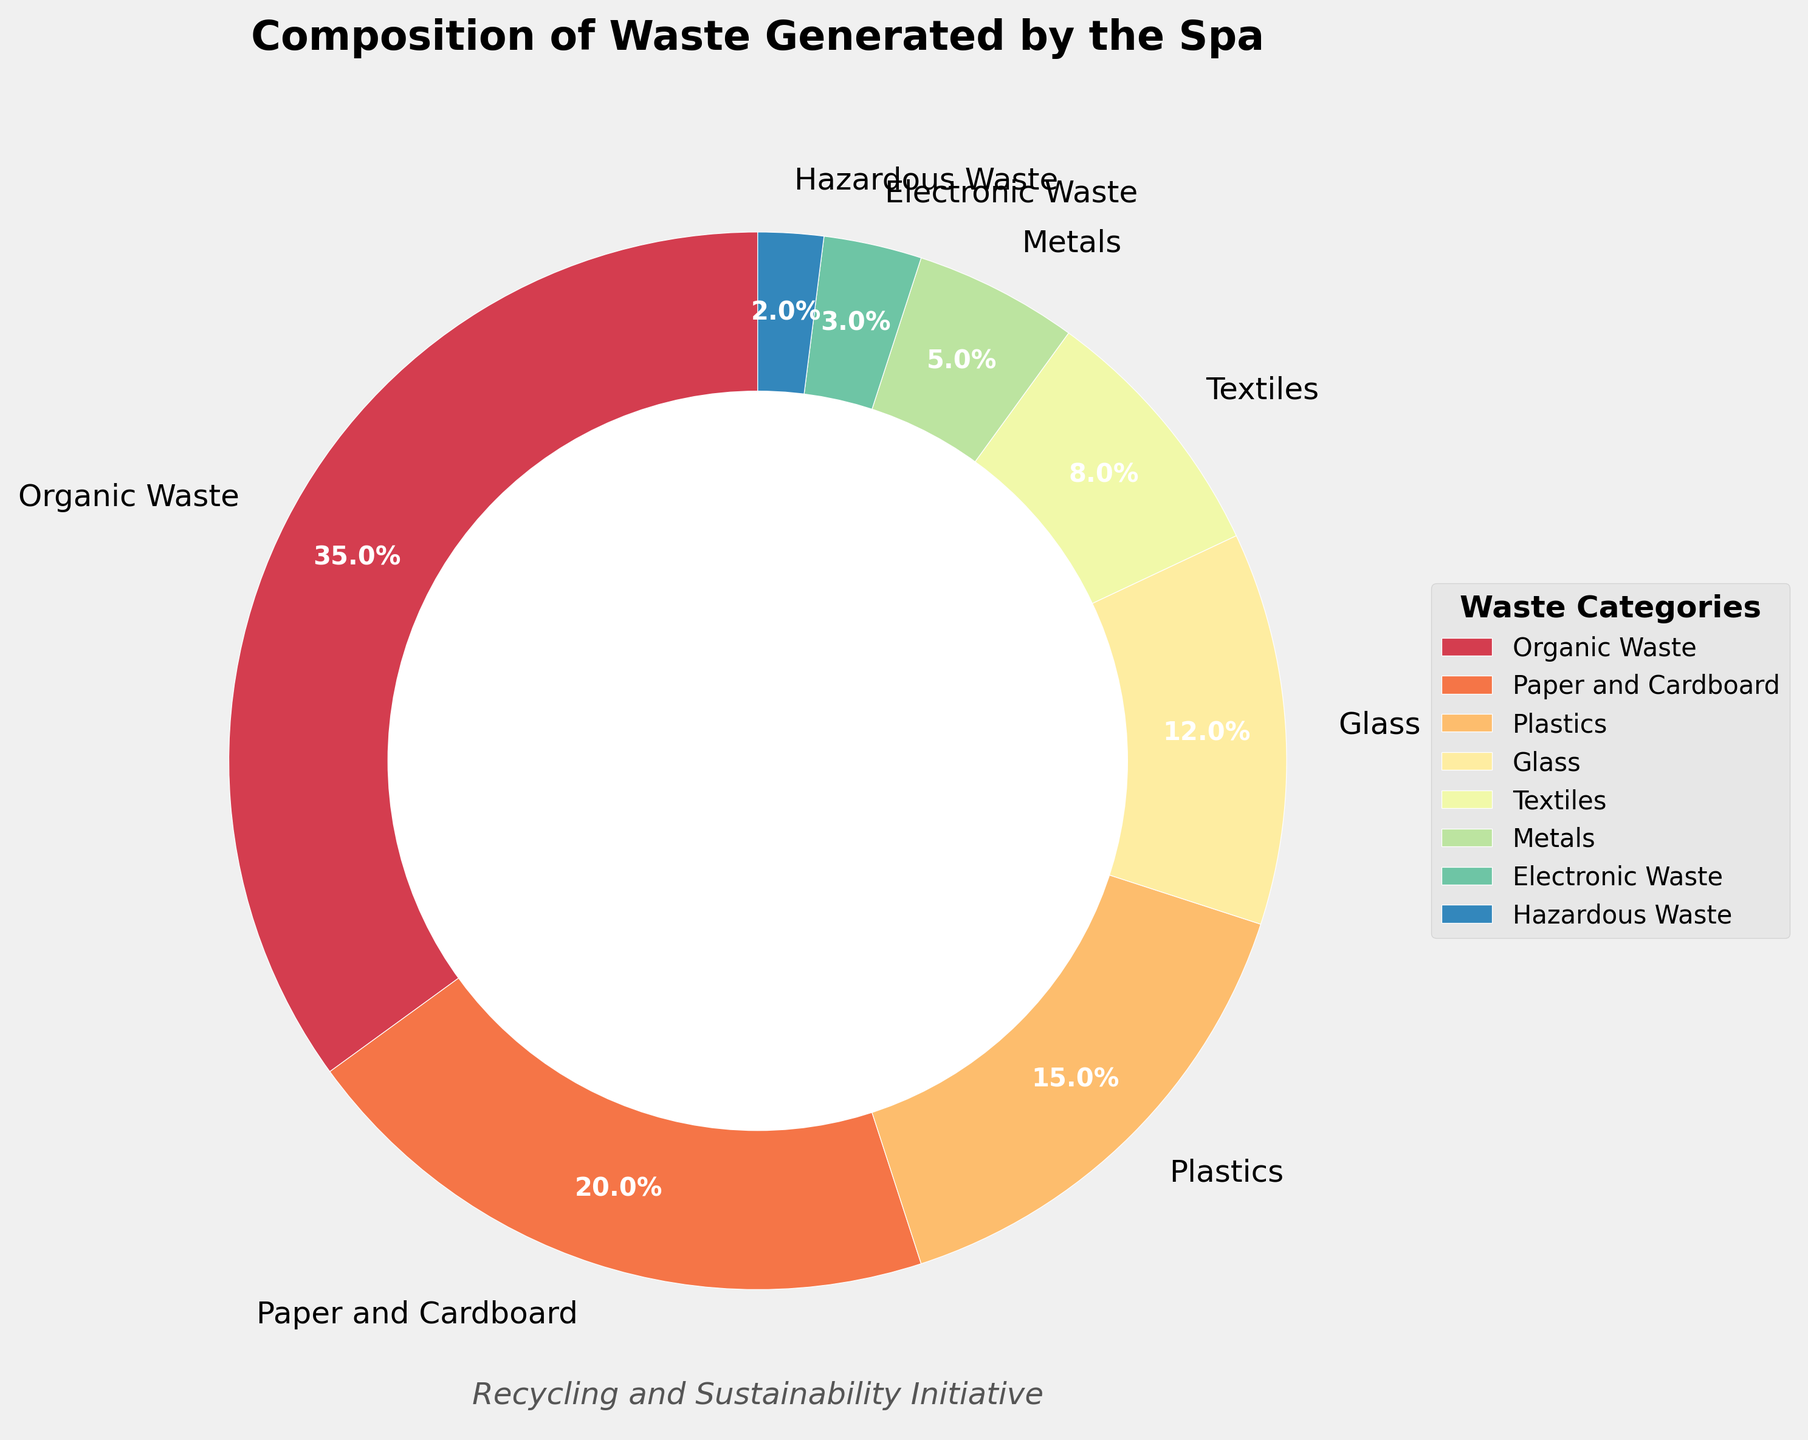Which category accounts for the largest percentage of waste? By observing the size of the wedges and their respective labels, we can see that the wedge labeled "Organic Waste" is the largest, with a percentage label of 35%.
Answer: Organic Waste How much more Organic Waste is generated compared to Plastics? The percentage of Organic Waste is 35%, and the percentage of Plastics is 15%. To find the difference, we subtract the percentage of Plastics from the percentage of Organic Waste: 35% - 15% = 20%.
Answer: 20% What is the combined percentage of Paper and Cardboard, Textiles, and Electronic Waste? Sum the percentages of Paper and Cardboard (20%), Textiles (8%), and Electronic Waste (3%) to get the total combined percentage: 20% + 8% + 3% = 31%.
Answer: 31% Which category has the smallest percentage of waste, and what is its exact value? By examining the labels and percentages, we see that "Hazardous Waste" has the smallest wedge in the pie chart with a value of 2%.
Answer: Hazardous Waste, 2% Is the percentage of Metals higher or lower than the percentage of Glass? By comparing the labels and the wedge sizes, we see that Metals are at 5%, while Glass is at 12%. Therefore, the percentage of Metals is lower than that of Glass.
Answer: Lower Which waste categories together make up exactly 50% of the total waste? Sum the percentages of various categories to find combinations that equal 50%. Organic Waste (35%) and Paper and Cardboard (20%) together exceed 50%. The correct combination is Organic Waste (35%) and Plastics (15%), whose sum is 35% + 15% = 50%.
Answer: Organic Waste and Plastics What is the percentage difference between Textiles and Electronic Waste? To find the difference, subtract the percentage of Electronic Waste (3%) from the percentage of Textiles (8%): 8% - 3% = 5%.
Answer: 5% How does the percentage of Textiles compare to that of Metals? Comparing the wedges and their labels, Textiles account for 8% while Metals account for 5%. Textiles have a higher percentage than Metals.
Answer: Textiles have a higher percentage What is the total percentage of categories that individually account for less than 10% of the waste? Sum the percentages of Textiles (8%), Metals (5%), Electronic Waste (3%), and Hazardous Waste (2%): 8% + 5% + 3% + 2% = 18%.
Answer: 18% What is the difference between the combined percentage of categories with more than 10% waste and those with less than 10% waste? First, sum the percentages of categories with more than 10%: Organic Waste (35%) + Paper and Cardboard (20%) + Plastics (15%) + Glass (12%) = 82%. Then, sum the categories with less than 10%: Textiles (8%), Metals (5%), Electronic Waste (3%), Hazardous Waste (2%) = 18%. Subtract the smaller sum from the larger sum: 82% - 18% = 64%.
Answer: 64% 